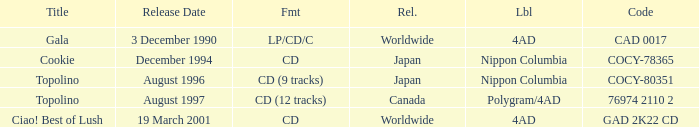What Label released an album in August 1996? Nippon Columbia. 